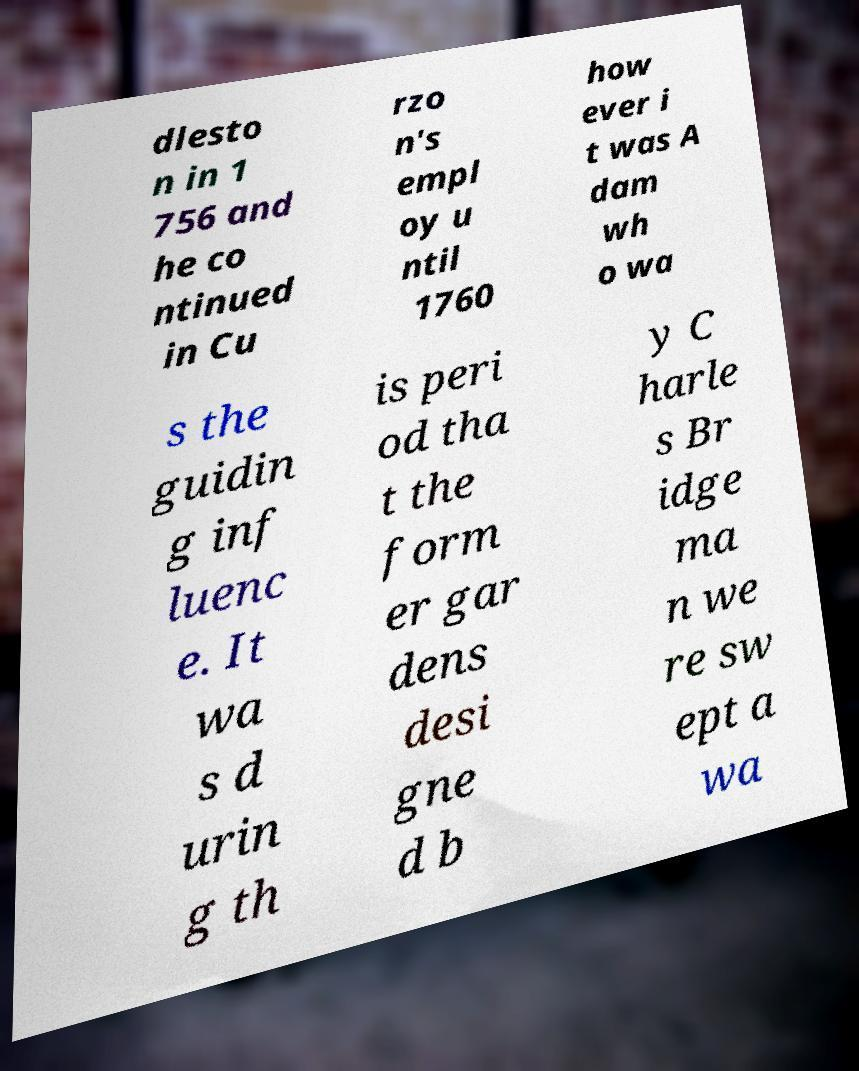Could you extract and type out the text from this image? dlesto n in 1 756 and he co ntinued in Cu rzo n's empl oy u ntil 1760 how ever i t was A dam wh o wa s the guidin g inf luenc e. It wa s d urin g th is peri od tha t the form er gar dens desi gne d b y C harle s Br idge ma n we re sw ept a wa 